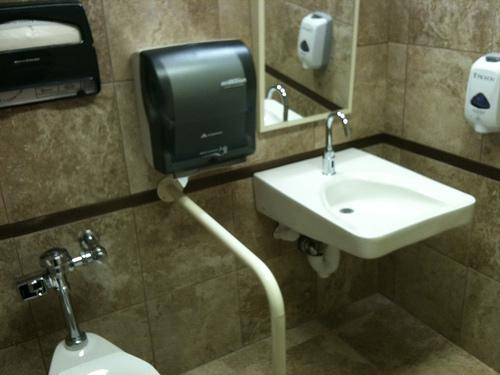Question: where was this picture taken?
Choices:
A. Bedroom.
B. Bathroom.
C. Kitchen.
D. Living room.
Answer with the letter. Answer: B Question: how many mirrors are in the picture?
Choices:
A. Two.
B. One.
C. Five.
D. Three.
Answer with the letter. Answer: B Question: where is the sink mounted?
Choices:
A. By the counter.
B. In the kitchen.
C. On the wall.
D. In the bathroom.
Answer with the letter. Answer: C Question: what color is the faucet?
Choices:
A. Silver.
B. Gold.
C. Platinum.
D. Bronze.
Answer with the letter. Answer: A 